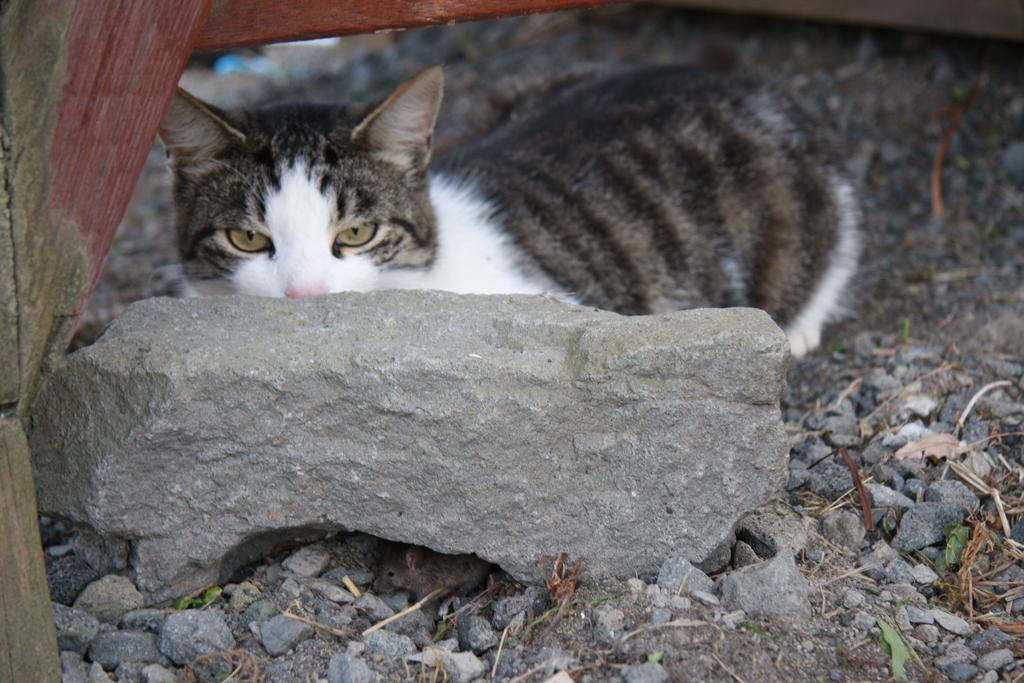What animal can be seen in the picture? There is a cat in the picture. Where is the cat located in relation to other objects in the image? The cat is sitting behind a rock. Are there any other animals present in the image? Yes, there is a rat in the picture. What type of terrain is visible in the image? There are stones and soil on the floor. What type of impulse can be seen affecting the cat's behavior in the image? There is no mention of any impulse affecting the cat's behavior in the image. Can you describe the mountain range visible in the background of the image? There is no mountain range visible in the image; it features a cat sitting behind a rock and a rat. 